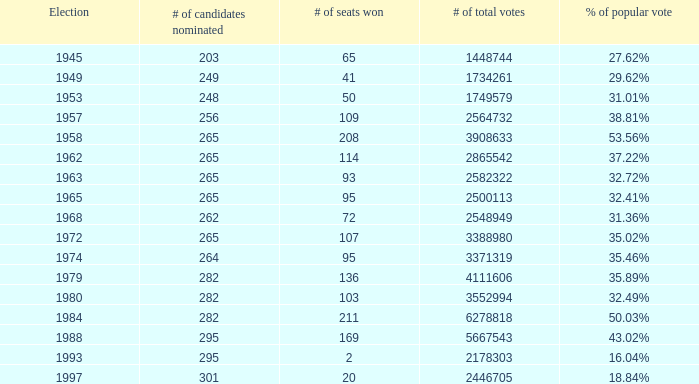What was the lowest # of total votes? 1448744.0. 